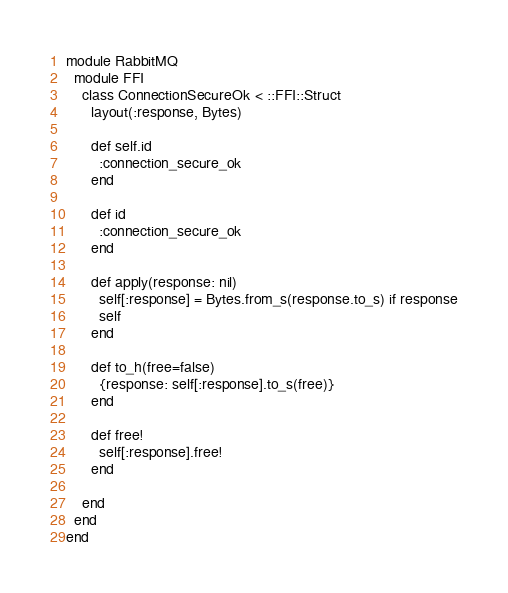Convert code to text. <code><loc_0><loc_0><loc_500><loc_500><_Ruby_>
module RabbitMQ
  module FFI
    class ConnectionSecureOk < ::FFI::Struct
      layout(:response, Bytes)
      
      def self.id
        :connection_secure_ok
      end
      
      def id
        :connection_secure_ok
      end
      
      def apply(response: nil)
        self[:response] = Bytes.from_s(response.to_s) if response
        self
      end
      
      def to_h(free=false)
        {response: self[:response].to_s(free)}
      end
      
      def free!
        self[:response].free!
      end
      
    end
  end
end
</code> 